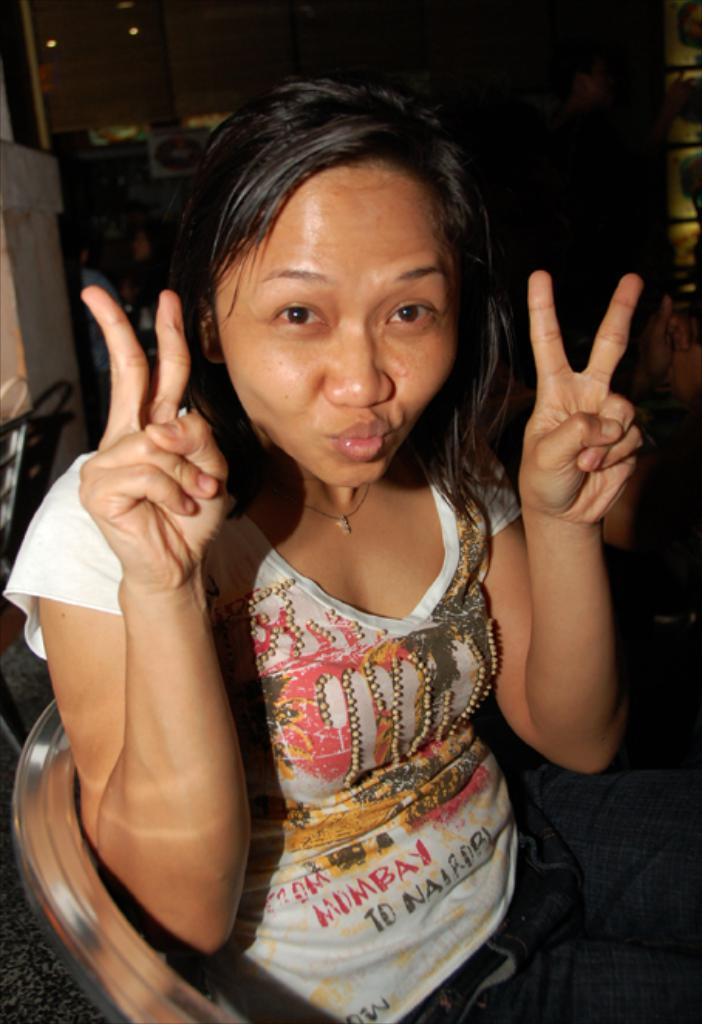Who is the main subject in the image? There is a girl in the image. What is the girl doing with her hands? The girl is showing her two hands in the image. What is the girl wearing? The girl is wearing a white t-shirt. What type of space exploration equipment can be seen in the image? There is no space exploration equipment present in the image; it features a girl showing her two hands while wearing a white t-shirt. What title is given to the girl in the image? There is no title given to the girl in the image; she is simply referred to as a girl. 